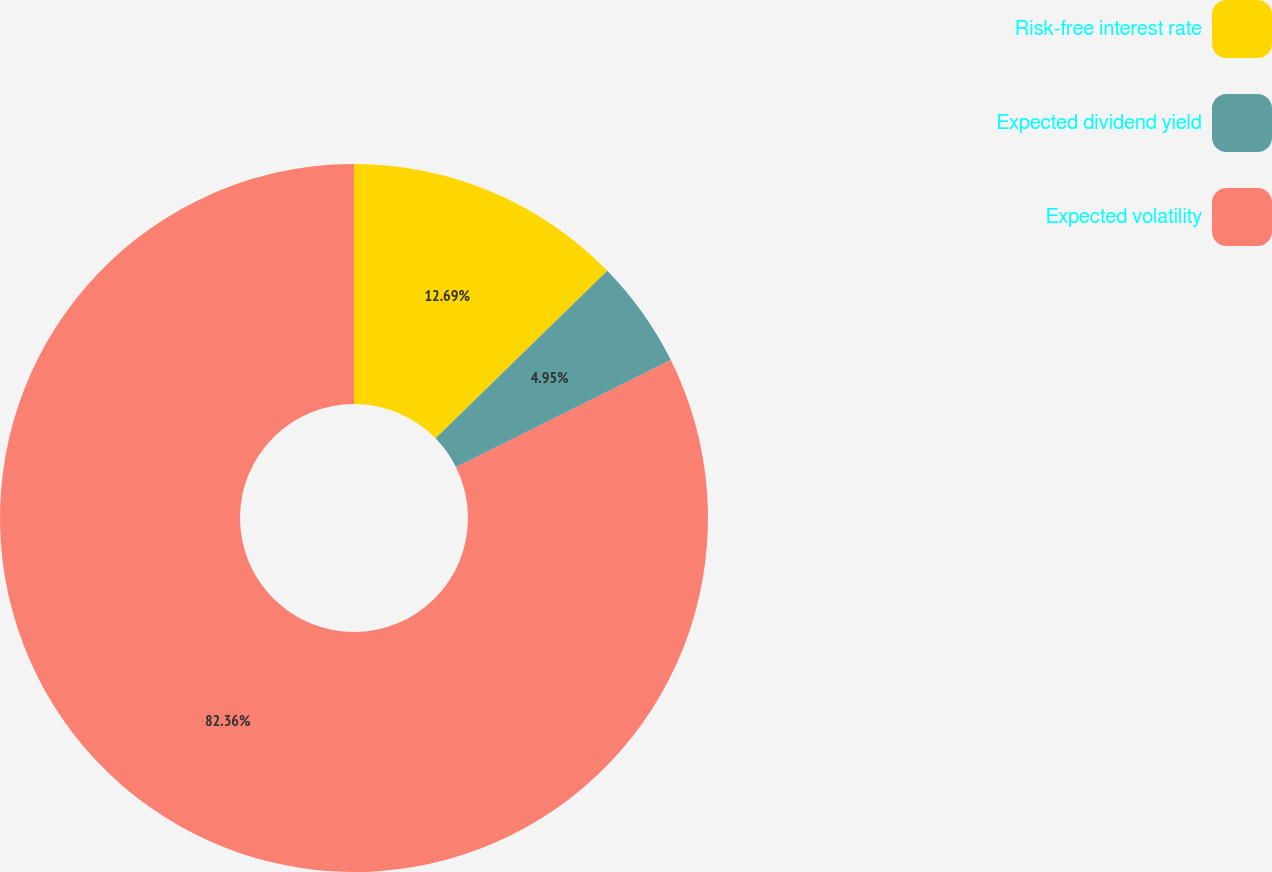<chart> <loc_0><loc_0><loc_500><loc_500><pie_chart><fcel>Risk-free interest rate<fcel>Expected dividend yield<fcel>Expected volatility<nl><fcel>12.69%<fcel>4.95%<fcel>82.35%<nl></chart> 